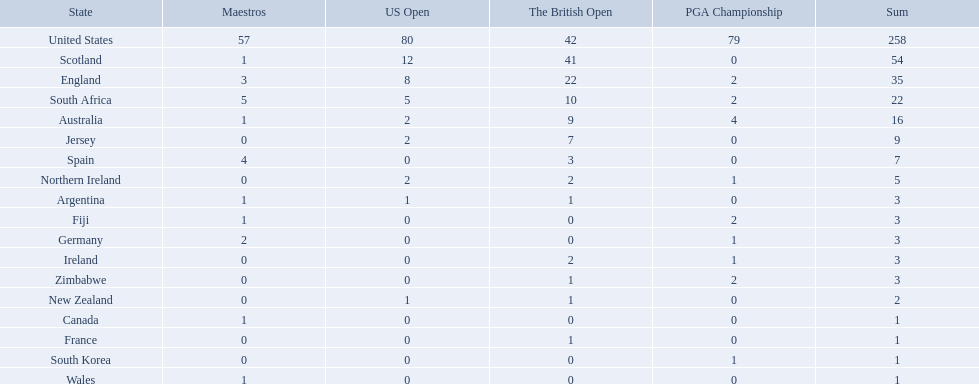What countries in the championship were from africa? South Africa, Zimbabwe. Which of these counteries had the least championship golfers Zimbabwe. 